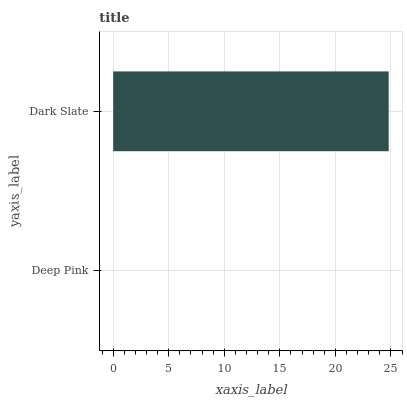Is Deep Pink the minimum?
Answer yes or no. Yes. Is Dark Slate the maximum?
Answer yes or no. Yes. Is Dark Slate the minimum?
Answer yes or no. No. Is Dark Slate greater than Deep Pink?
Answer yes or no. Yes. Is Deep Pink less than Dark Slate?
Answer yes or no. Yes. Is Deep Pink greater than Dark Slate?
Answer yes or no. No. Is Dark Slate less than Deep Pink?
Answer yes or no. No. Is Dark Slate the high median?
Answer yes or no. Yes. Is Deep Pink the low median?
Answer yes or no. Yes. Is Deep Pink the high median?
Answer yes or no. No. Is Dark Slate the low median?
Answer yes or no. No. 